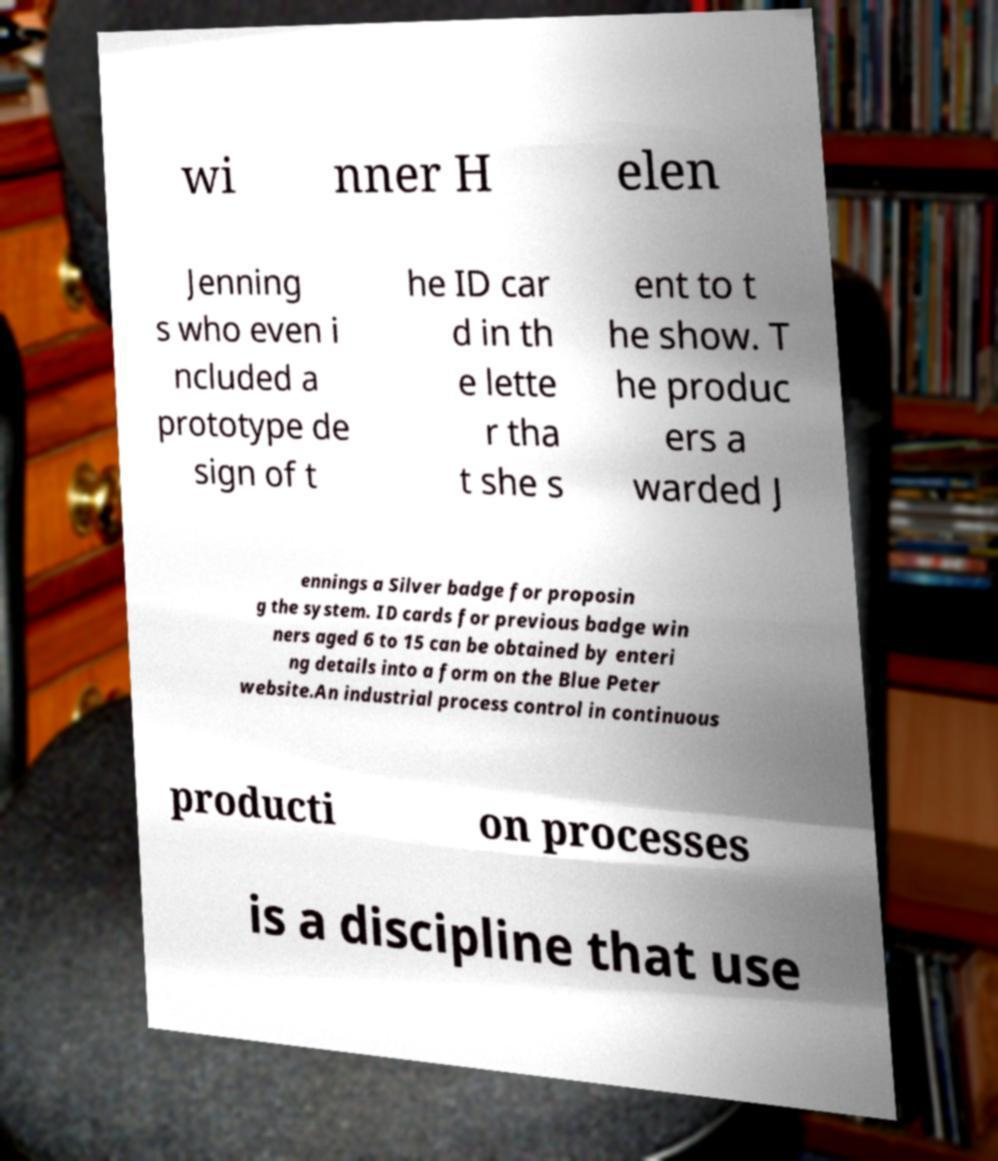Can you accurately transcribe the text from the provided image for me? wi nner H elen Jenning s who even i ncluded a prototype de sign of t he ID car d in th e lette r tha t she s ent to t he show. T he produc ers a warded J ennings a Silver badge for proposin g the system. ID cards for previous badge win ners aged 6 to 15 can be obtained by enteri ng details into a form on the Blue Peter website.An industrial process control in continuous producti on processes is a discipline that use 